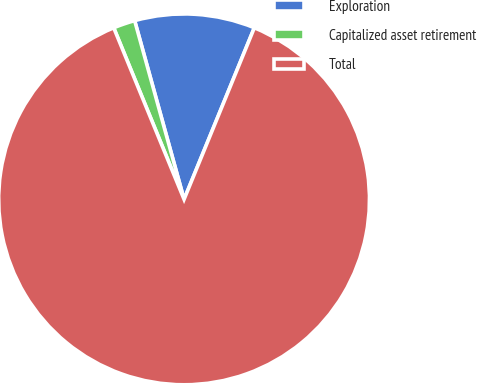Convert chart. <chart><loc_0><loc_0><loc_500><loc_500><pie_chart><fcel>Exploration<fcel>Capitalized asset retirement<fcel>Total<nl><fcel>10.48%<fcel>1.9%<fcel>87.62%<nl></chart> 